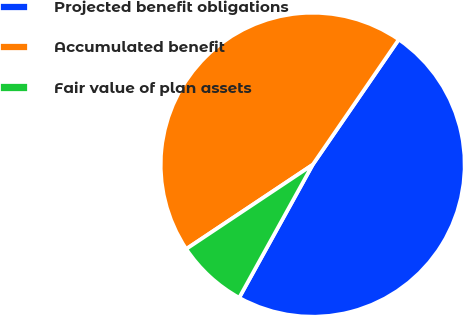Convert chart. <chart><loc_0><loc_0><loc_500><loc_500><pie_chart><fcel>Projected benefit obligations<fcel>Accumulated benefit<fcel>Fair value of plan assets<nl><fcel>48.45%<fcel>43.94%<fcel>7.61%<nl></chart> 